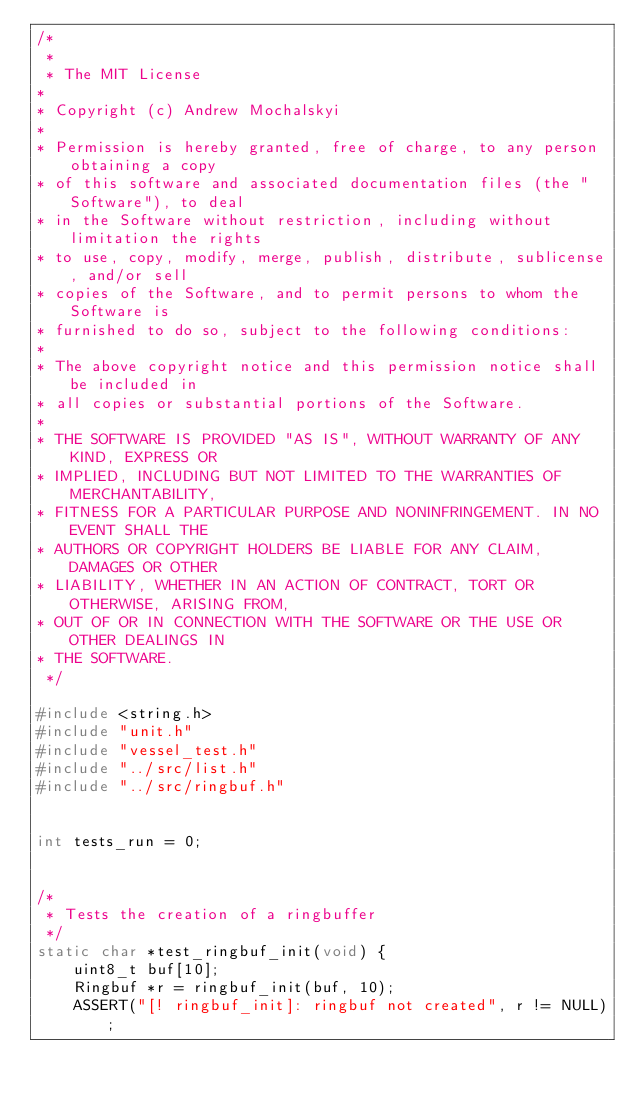<code> <loc_0><loc_0><loc_500><loc_500><_C_>/* 
 *
 * The MIT License
*
* Copyright (c) Andrew Mochalskyi
*
* Permission is hereby granted, free of charge, to any person obtaining a copy
* of this software and associated documentation files (the "Software"), to deal
* in the Software without restriction, including without limitation the rights
* to use, copy, modify, merge, publish, distribute, sublicense, and/or sell
* copies of the Software, and to permit persons to whom the Software is
* furnished to do so, subject to the following conditions:
*
* The above copyright notice and this permission notice shall be included in
* all copies or substantial portions of the Software.
*
* THE SOFTWARE IS PROVIDED "AS IS", WITHOUT WARRANTY OF ANY KIND, EXPRESS OR
* IMPLIED, INCLUDING BUT NOT LIMITED TO THE WARRANTIES OF MERCHANTABILITY,
* FITNESS FOR A PARTICULAR PURPOSE AND NONINFRINGEMENT. IN NO EVENT SHALL THE
* AUTHORS OR COPYRIGHT HOLDERS BE LIABLE FOR ANY CLAIM, DAMAGES OR OTHER
* LIABILITY, WHETHER IN AN ACTION OF CONTRACT, TORT OR OTHERWISE, ARISING FROM,
* OUT OF OR IN CONNECTION WITH THE SOFTWARE OR THE USE OR OTHER DEALINGS IN
* THE SOFTWARE.
 */

#include <string.h>
#include "unit.h"
#include "vessel_test.h"
#include "../src/list.h"
#include "../src/ringbuf.h"


int tests_run = 0;


/*
 * Tests the creation of a ringbuffer
 */
static char *test_ringbuf_init(void) {
    uint8_t buf[10];
    Ringbuf *r = ringbuf_init(buf, 10);
    ASSERT("[! ringbuf_init]: ringbuf not created", r != NULL);</code> 